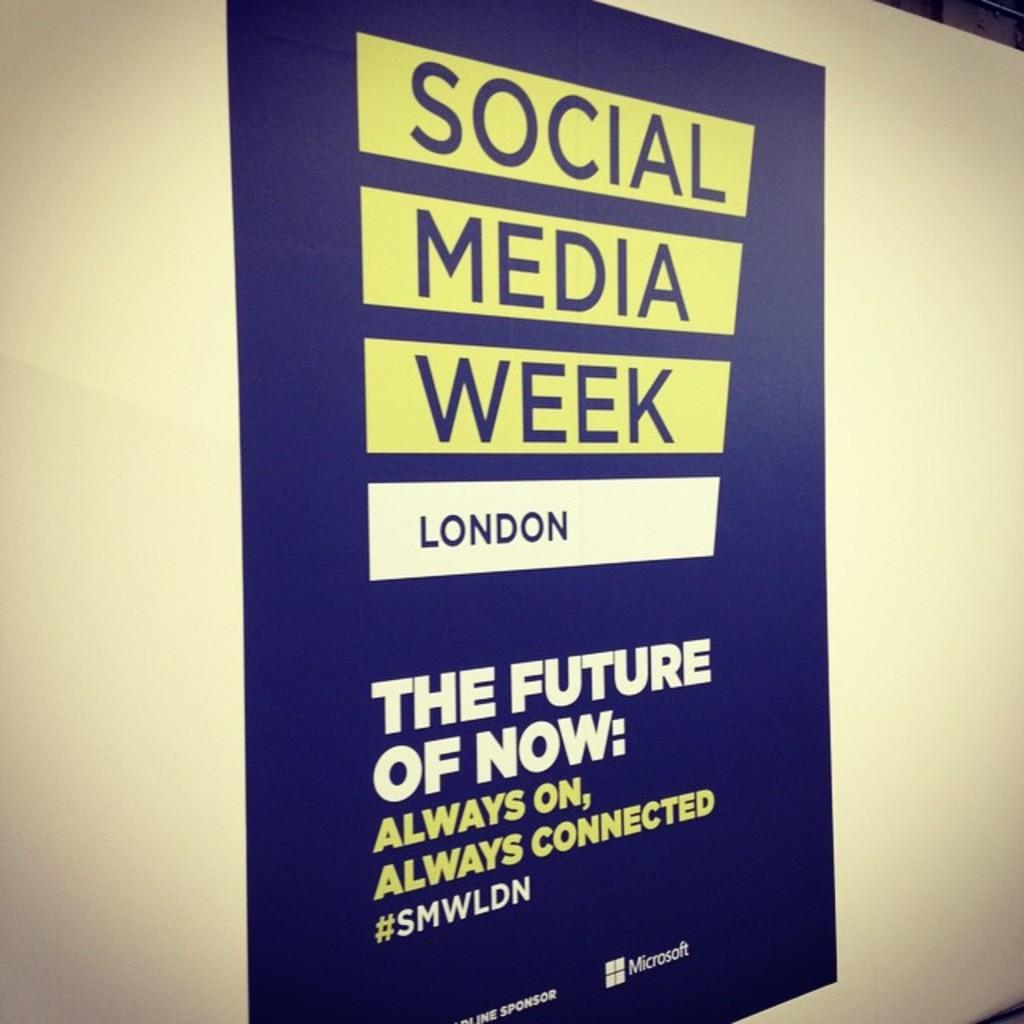<image>
Provide a brief description of the given image. A poster advertises Social Media Week in London. 